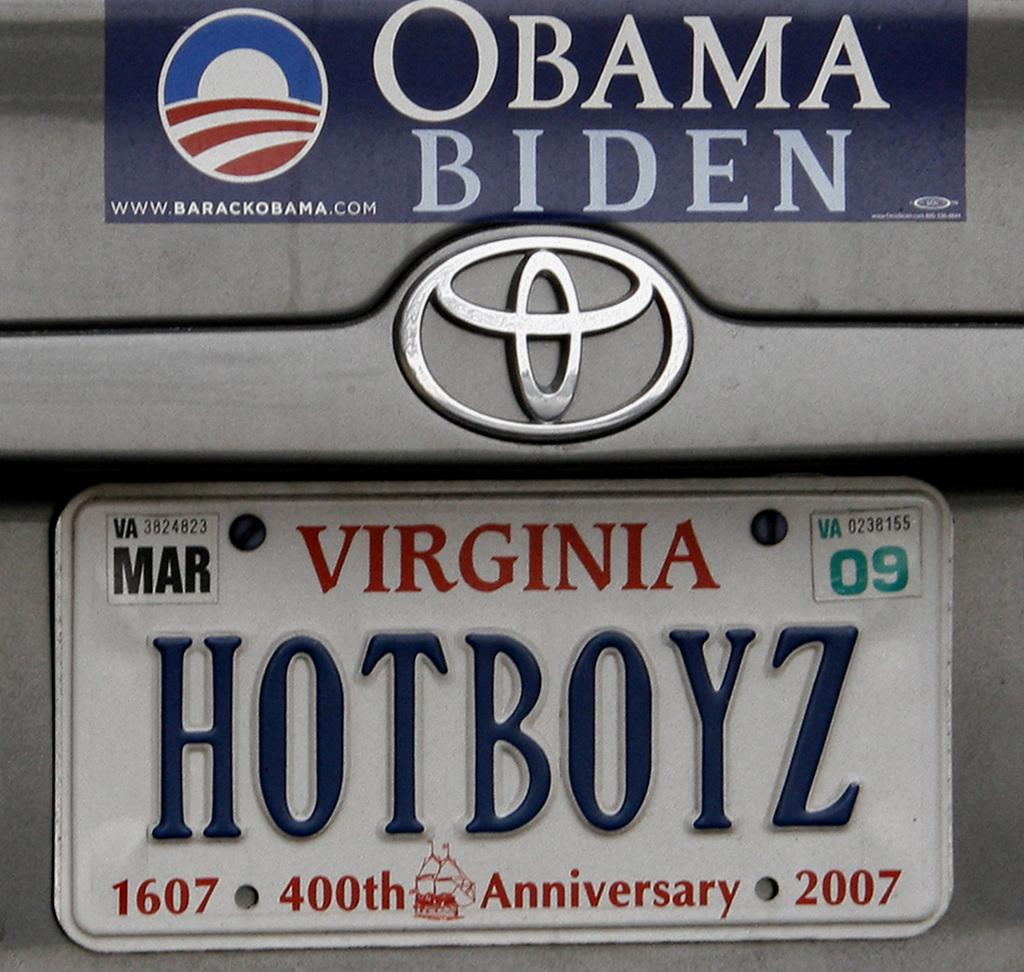<image>
Summarize the visual content of the image. A car that is owned by a Virginia democrat. 